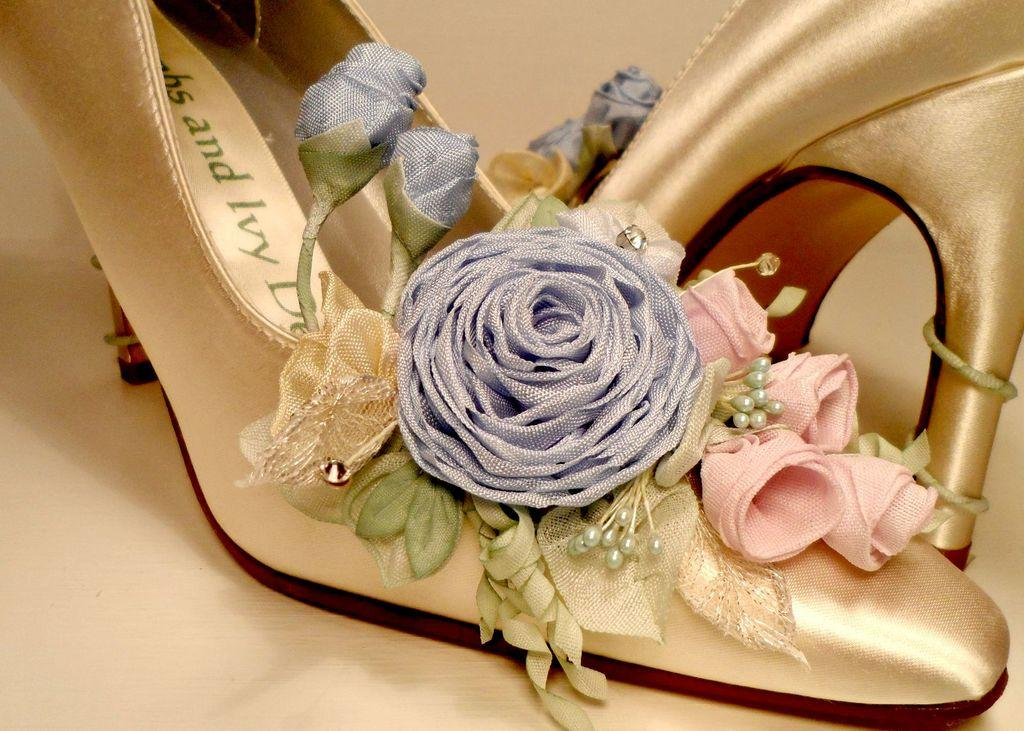What type of footwear is in the image? There is a pair of heels in the image. What design can be seen on the heels? The heels have a floral design. Where are the heels placed in the image? The heels are placed on a surface. What type of breakfast is being served on the heels in the image? There is no breakfast or any food present in the image; it only features a pair of heels with a floral design. 